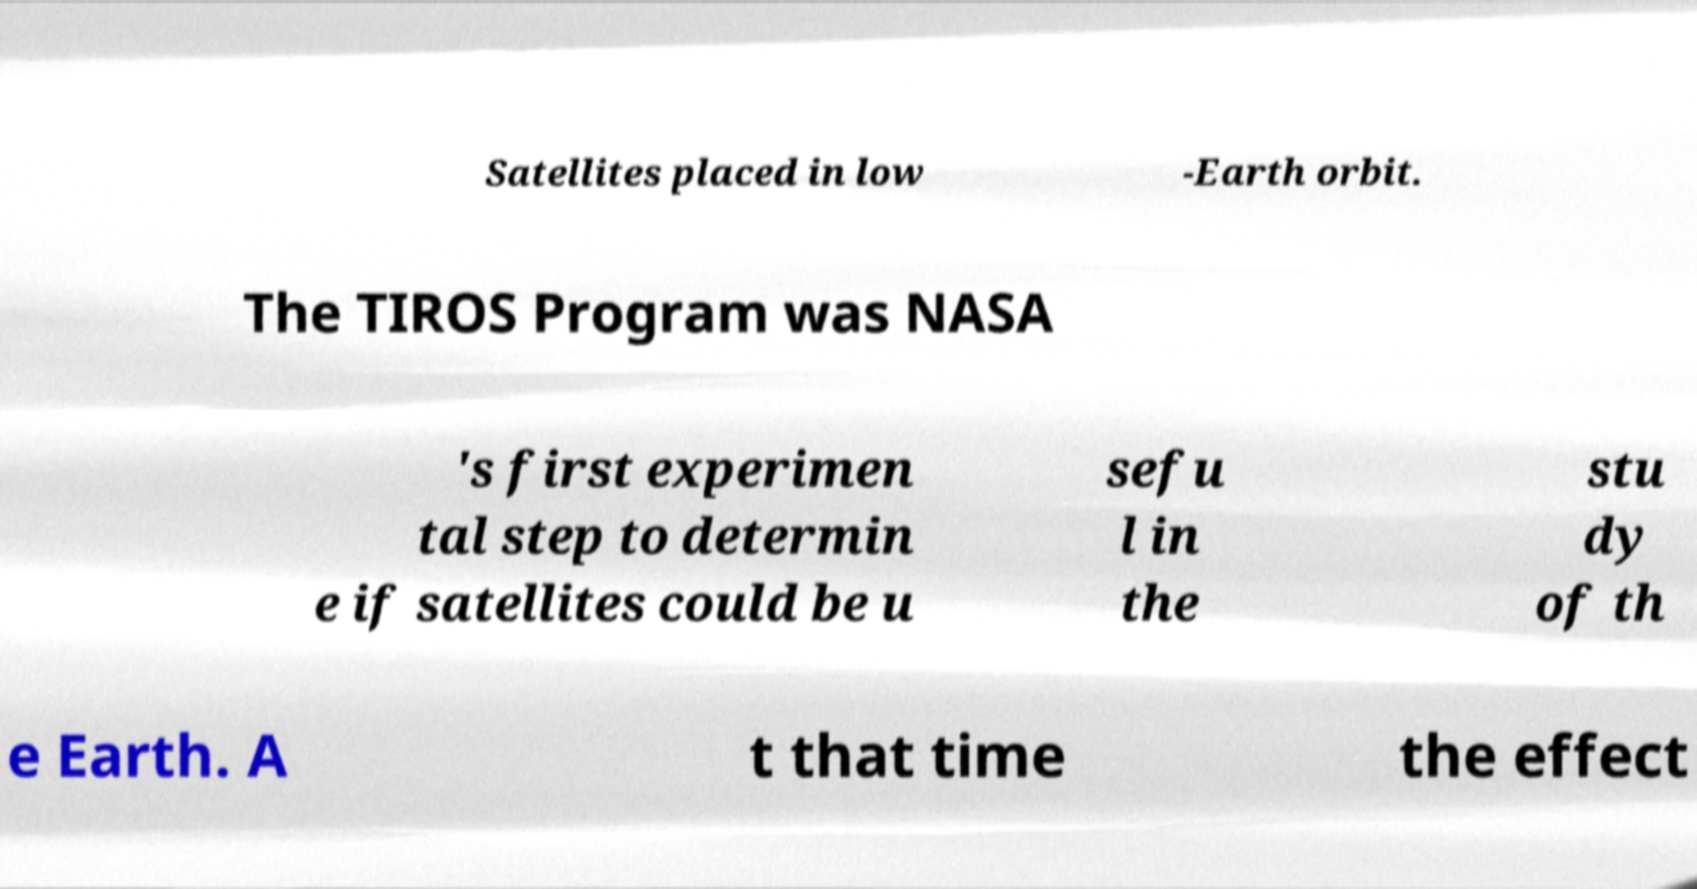I need the written content from this picture converted into text. Can you do that? Satellites placed in low -Earth orbit. The TIROS Program was NASA 's first experimen tal step to determin e if satellites could be u sefu l in the stu dy of th e Earth. A t that time the effect 